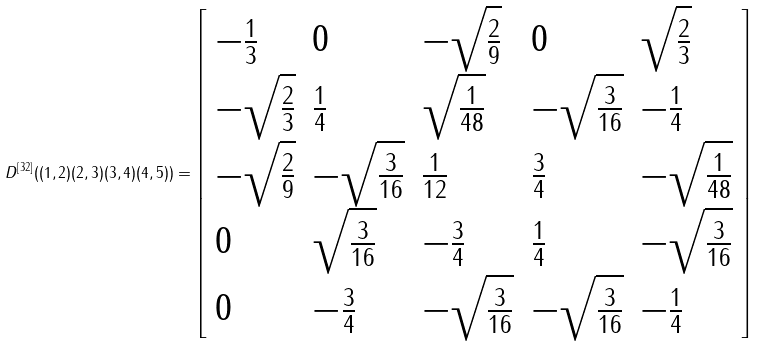Convert formula to latex. <formula><loc_0><loc_0><loc_500><loc_500>D ^ { \left [ 3 2 \right ] } ( ( 1 , 2 ) ( 2 , 3 ) ( 3 , 4 ) ( 4 , 5 ) ) = \left [ \begin{array} { l l l l l } - \frac { 1 } { 3 } & 0 & - \sqrt { \frac { 2 } { 9 } } & 0 & \sqrt { \frac { 2 } { 3 } } \\ - \sqrt { \frac { 2 } { 3 } } & \frac { 1 } { 4 } & \sqrt { \frac { 1 } { 4 8 } } & - \sqrt { \frac { 3 } { 1 6 } } & - \frac { 1 } { 4 } \\ - \sqrt { \frac { 2 } { 9 } } & - \sqrt { \frac { 3 } { 1 6 } } & \frac { 1 } { 1 2 } & \frac { 3 } { 4 } & - \sqrt { \frac { 1 } { 4 8 } } \\ 0 & \sqrt { \frac { 3 } { 1 6 } } & - \frac { 3 } { 4 } & \frac { 1 } { 4 } & - \sqrt { \frac { 3 } { 1 6 } } \\ 0 & - \frac { 3 } { 4 } & - \sqrt { \frac { 3 } { 1 6 } } & - \sqrt { \frac { 3 } { 1 6 } } & - \frac { 1 } { 4 } \end{array} \right ]</formula> 